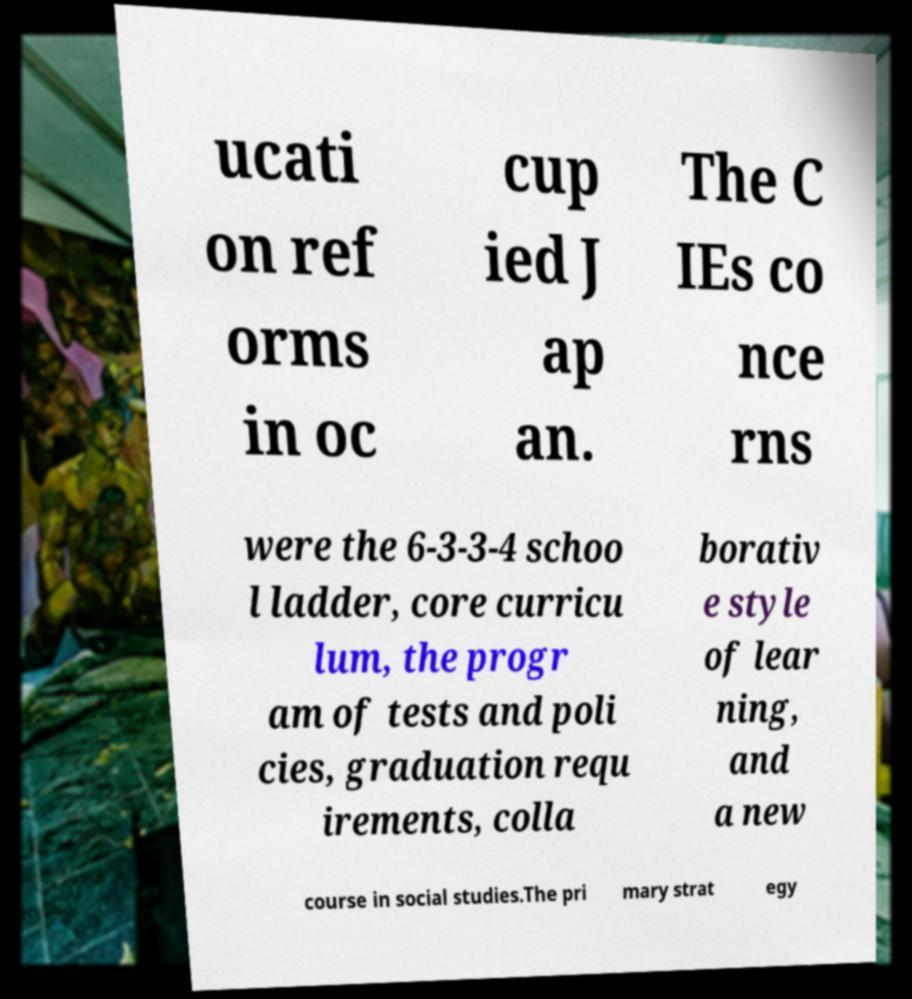I need the written content from this picture converted into text. Can you do that? ucati on ref orms in oc cup ied J ap an. The C IEs co nce rns were the 6-3-3-4 schoo l ladder, core curricu lum, the progr am of tests and poli cies, graduation requ irements, colla borativ e style of lear ning, and a new course in social studies.The pri mary strat egy 